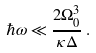Convert formula to latex. <formula><loc_0><loc_0><loc_500><loc_500>\hbar { \omega } \ll \frac { 2 \Omega _ { 0 } ^ { 3 } } { \kappa \Delta } \, .</formula> 